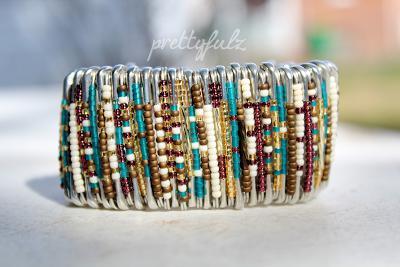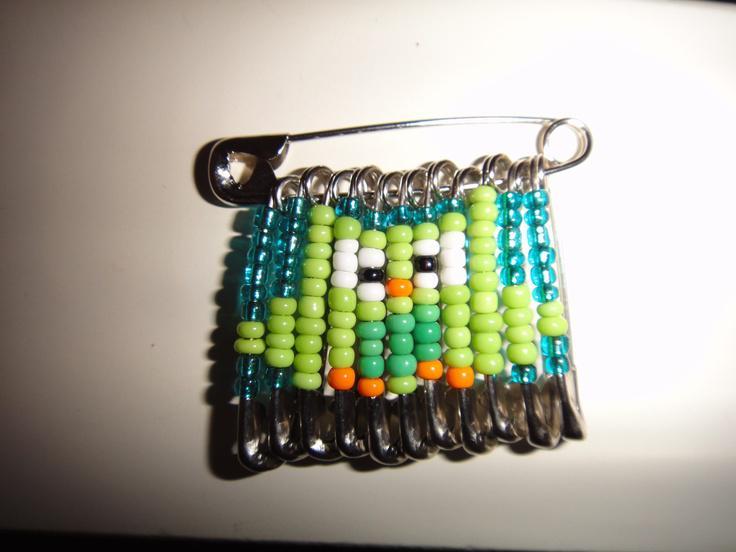The first image is the image on the left, the second image is the image on the right. For the images shown, is this caption "In one of the pictures, the beads are arranged to resemble an owl." true? Answer yes or no. Yes. The first image is the image on the left, the second image is the image on the right. Examine the images to the left and right. Is the description "An image contains one pin jewelry with colored beads strung on silver safety pins to create a cartoon-like owl image." accurate? Answer yes or no. Yes. 